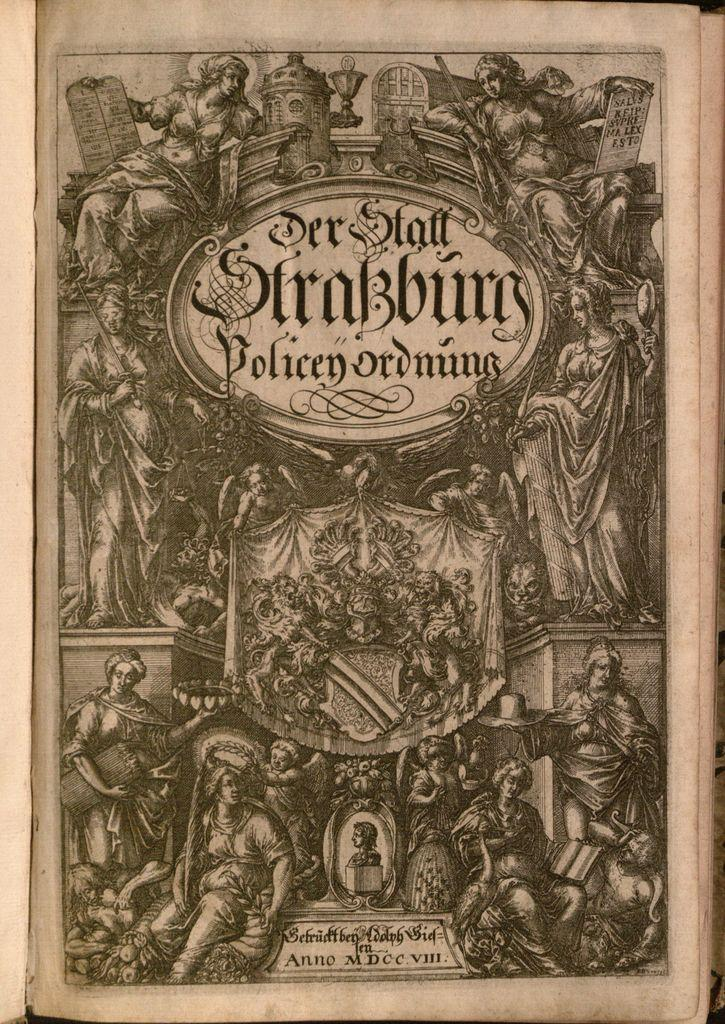<image>
Share a concise interpretation of the image provided. An old book cover with one of the words on it saying "policenordnung" 